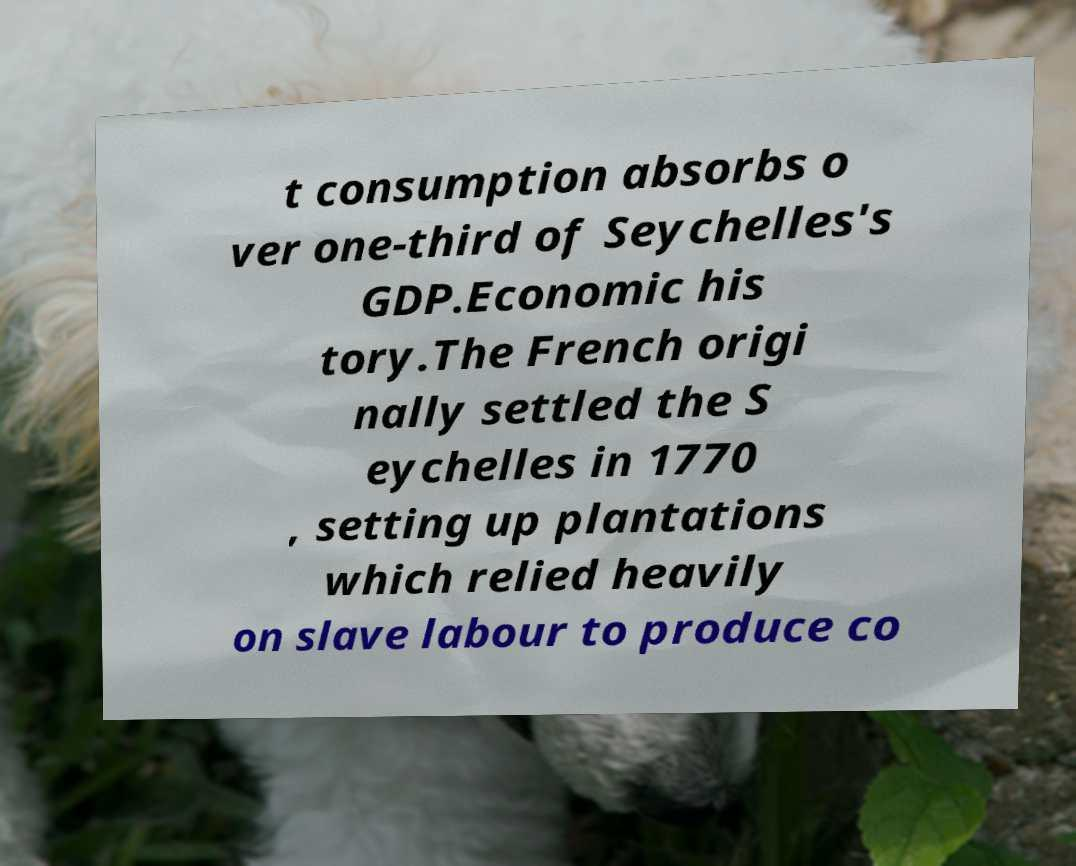Could you assist in decoding the text presented in this image and type it out clearly? t consumption absorbs o ver one-third of Seychelles's GDP.Economic his tory.The French origi nally settled the S eychelles in 1770 , setting up plantations which relied heavily on slave labour to produce co 